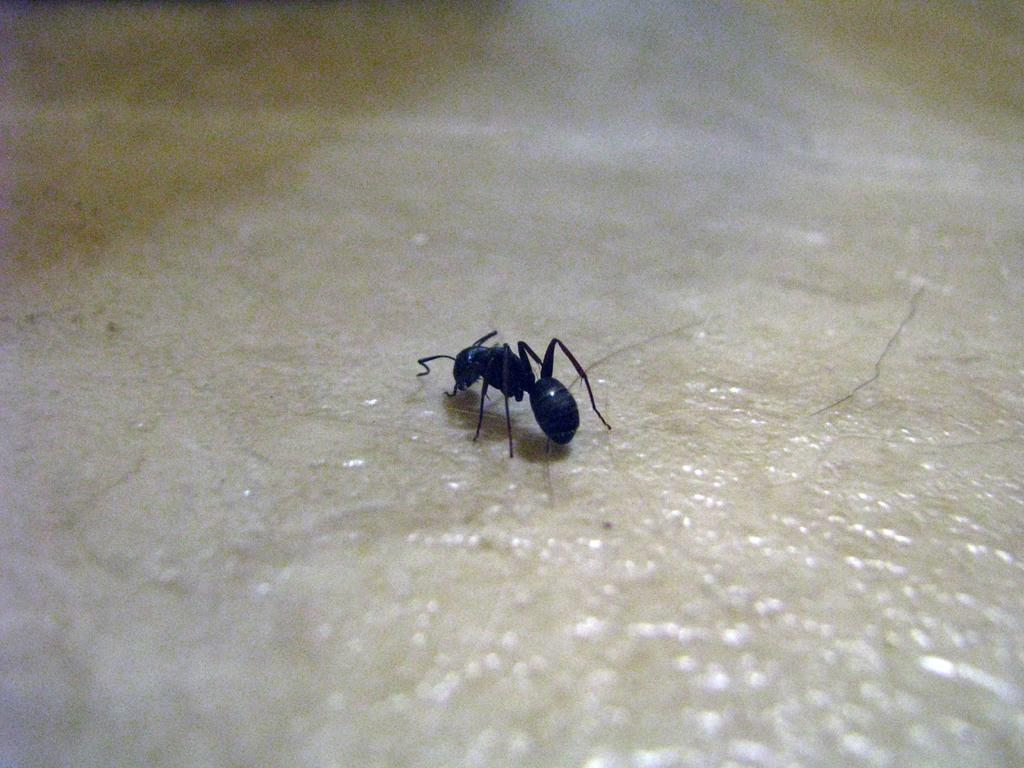What type of insect is present in the image? There is an ant in the image. What color is the ant? The ant is black in color. Where is the prison located in the image? There is no prison present in the image; it features an ant. What time does the clock show in the image? There is no clock present in the image. 